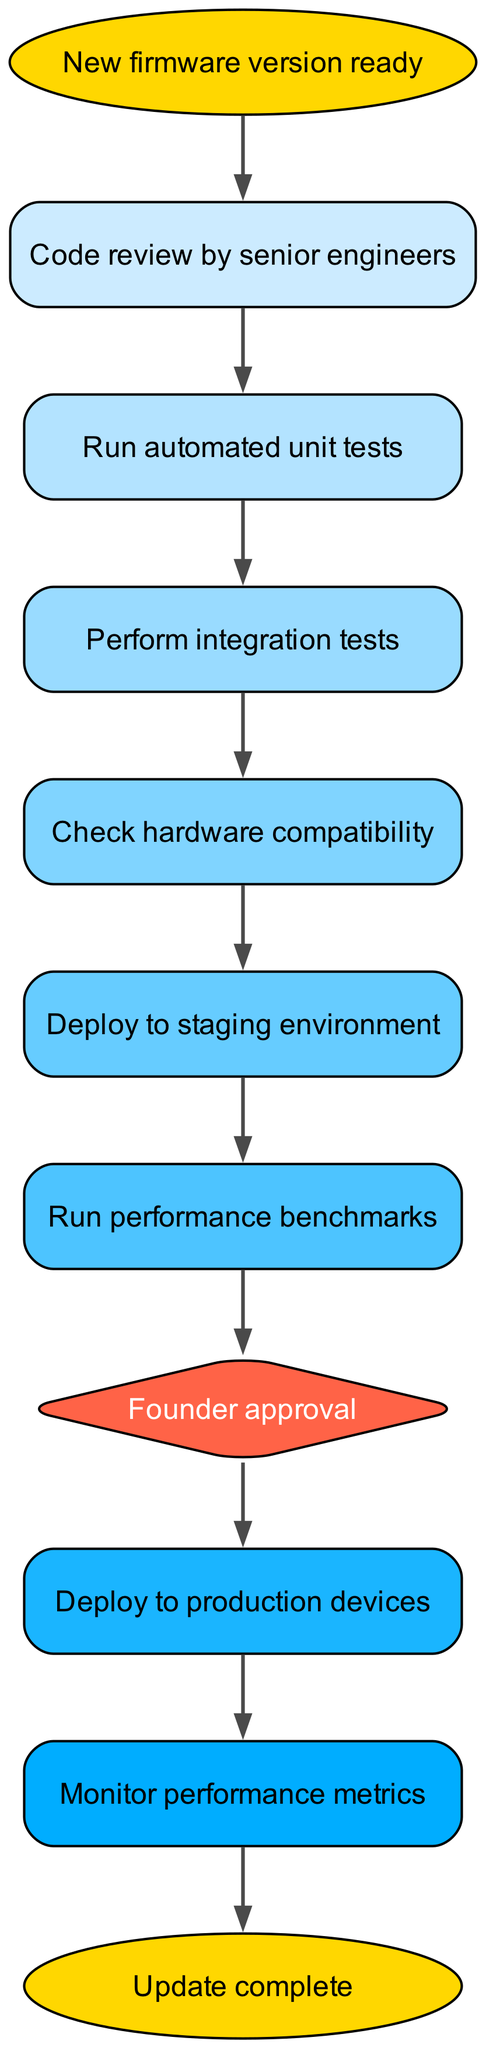What is the first step in the pipeline? The first step in the pipeline is indicated by the "start" node, which states "New firmware version ready." This node is positioned at the top of the flowchart, signifying the initial action that triggers the process.
Answer: New firmware version ready How many stages are there in the testing process before the founder's approval? To find the number of stages before "Founder approval," we follow the flow from "unit tests" through "integration tests," "hardware compatibility," and "staging," totaling four stages. This involves counting each node connected sequentially before approval.
Answer: Four What is the last step after monitoring? The last step in the pipeline is indicated by the "end" node, which signifies the completion of the update process after monitoring. This is the final node in the flowchart, representing the conclusion of the entire pipeline.
Answer: Update complete Which node requires an approval from the founder? The "approval" node is a diamond-shaped node that specifically indicates that founder approval is required before proceeding to the production stage. Its distinct shape and wording highlight its importance in the process.
Answer: Founder approval What happens after performing integration tests? After "Perform integration tests," the next step in the pipeline is to "Check hardware compatibility." This connection shows the sequential dependency, illustrating that hardware compatibility must be verified following the integration tests.
Answer: Check hardware compatibility How many connections are there in the entire diagram? The total number of connections in the diagram can be counted by reviewing all the edges that connect the nodes. By counting each connection listed in the connections data, we find there are ten connections.
Answer: Ten What type of node follows the performance benchmarks stage? Following the "Run performance benchmarks" stage, the process moves to the "Founder approval" stage, which is represented as a diamond node. This specific arrangement indicates that approval is a decision point in the pipeline.
Answer: Founder approval What indicates the start of the update process in the flowchart? The "start" node, labeled "New firmware version ready," clearly indicates the beginning of the update process within the flowchart structure, marking the initiation point from which the subsequent actions will flow.
Answer: New firmware version ready 